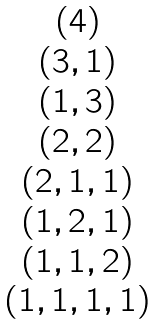Convert formula to latex. <formula><loc_0><loc_0><loc_500><loc_500>\begin{matrix} { ( 4 ) } \\ { ( 3 , 1 ) } \\ { ( 1 , 3 ) } \\ { ( 2 , 2 ) } \\ { ( 2 , 1 , 1 ) } \\ { ( 1 , 2 , 1 ) } \\ { ( 1 , 1 , 2 ) } \\ { ( 1 , 1 , 1 , 1 ) } \end{matrix}</formula> 